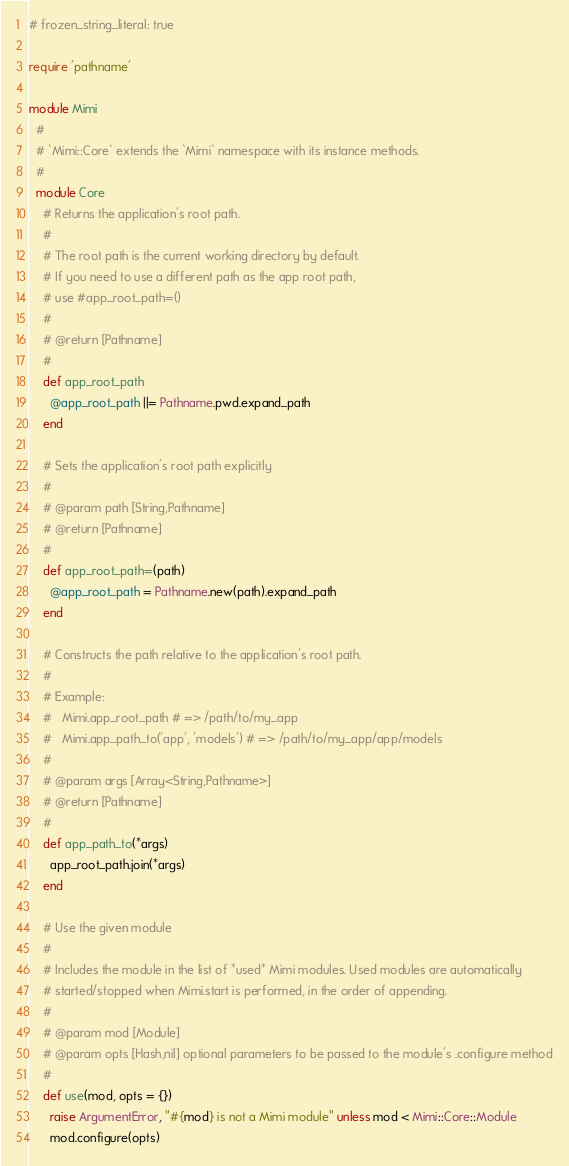Convert code to text. <code><loc_0><loc_0><loc_500><loc_500><_Ruby_># frozen_string_literal: true

require 'pathname'

module Mimi
  #
  # `Mimi::Core` extends the `Mimi` namespace with its instance methods.
  #
  module Core
    # Returns the application's root path.
    #
    # The root path is the current working directory by default.
    # If you need to use a different path as the app root path,
    # use #app_root_path=()
    #
    # @return [Pathname]
    #
    def app_root_path
      @app_root_path ||= Pathname.pwd.expand_path
    end

    # Sets the application's root path explicitly
    #
    # @param path [String,Pathname]
    # @return [Pathname]
    #
    def app_root_path=(path)
      @app_root_path = Pathname.new(path).expand_path
    end

    # Constructs the path relative to the application's root path.
    #
    # Example:
    #   Mimi.app_root_path # => /path/to/my_app
    #   Mimi.app_path_to('app', 'models') # => /path/to/my_app/app/models
    #
    # @param args [Array<String,Pathname>]
    # @return [Pathname]
    #
    def app_path_to(*args)
      app_root_path.join(*args)
    end

    # Use the given module
    #
    # Includes the module in the list of *used* Mimi modules. Used modules are automatically
    # started/stopped when Mimi.start is performed, in the order of appending.
    #
    # @param mod [Module]
    # @param opts [Hash,nil] optional parameters to be passed to the module's .configure method
    #
    def use(mod, opts = {})
      raise ArgumentError, "#{mod} is not a Mimi module" unless mod < Mimi::Core::Module
      mod.configure(opts)</code> 